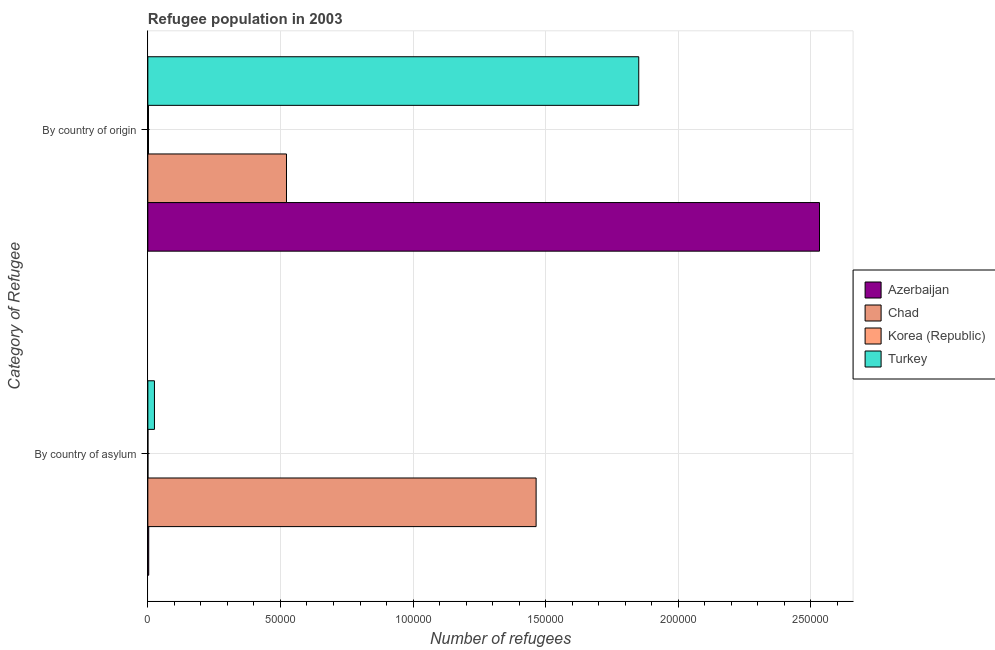How many different coloured bars are there?
Offer a very short reply. 4. Are the number of bars per tick equal to the number of legend labels?
Your response must be concise. Yes. Are the number of bars on each tick of the Y-axis equal?
Your answer should be compact. Yes. How many bars are there on the 2nd tick from the bottom?
Your answer should be compact. 4. What is the label of the 1st group of bars from the top?
Give a very brief answer. By country of origin. What is the number of refugees by country of asylum in Chad?
Offer a terse response. 1.46e+05. Across all countries, what is the maximum number of refugees by country of asylum?
Make the answer very short. 1.46e+05. Across all countries, what is the minimum number of refugees by country of asylum?
Your answer should be very brief. 25. In which country was the number of refugees by country of origin maximum?
Offer a very short reply. Azerbaijan. What is the total number of refugees by country of asylum in the graph?
Provide a succinct answer. 1.49e+05. What is the difference between the number of refugees by country of asylum in Chad and that in Turkey?
Your answer should be compact. 1.44e+05. What is the difference between the number of refugees by country of origin in Korea (Republic) and the number of refugees by country of asylum in Chad?
Your response must be concise. -1.46e+05. What is the average number of refugees by country of asylum per country?
Give a very brief answer. 3.73e+04. What is the difference between the number of refugees by country of origin and number of refugees by country of asylum in Azerbaijan?
Your answer should be compact. 2.53e+05. What is the ratio of the number of refugees by country of origin in Korea (Republic) to that in Turkey?
Make the answer very short. 0. Is the number of refugees by country of origin in Korea (Republic) less than that in Chad?
Your response must be concise. Yes. In how many countries, is the number of refugees by country of origin greater than the average number of refugees by country of origin taken over all countries?
Provide a succinct answer. 2. What does the 2nd bar from the top in By country of origin represents?
Offer a terse response. Korea (Republic). What does the 1st bar from the bottom in By country of asylum represents?
Give a very brief answer. Azerbaijan. How many bars are there?
Your answer should be compact. 8. Are all the bars in the graph horizontal?
Offer a terse response. Yes. How many countries are there in the graph?
Keep it short and to the point. 4. Does the graph contain any zero values?
Offer a very short reply. No. How many legend labels are there?
Ensure brevity in your answer.  4. What is the title of the graph?
Your answer should be very brief. Refugee population in 2003. Does "Oman" appear as one of the legend labels in the graph?
Offer a very short reply. No. What is the label or title of the X-axis?
Provide a succinct answer. Number of refugees. What is the label or title of the Y-axis?
Provide a short and direct response. Category of Refugee. What is the Number of refugees of Azerbaijan in By country of asylum?
Your response must be concise. 326. What is the Number of refugees of Chad in By country of asylum?
Make the answer very short. 1.46e+05. What is the Number of refugees in Turkey in By country of asylum?
Make the answer very short. 2490. What is the Number of refugees in Azerbaijan in By country of origin?
Your response must be concise. 2.53e+05. What is the Number of refugees in Chad in By country of origin?
Make the answer very short. 5.23e+04. What is the Number of refugees of Korea (Republic) in By country of origin?
Provide a short and direct response. 237. What is the Number of refugees of Turkey in By country of origin?
Keep it short and to the point. 1.85e+05. Across all Category of Refugee, what is the maximum Number of refugees in Azerbaijan?
Offer a very short reply. 2.53e+05. Across all Category of Refugee, what is the maximum Number of refugees of Chad?
Your answer should be compact. 1.46e+05. Across all Category of Refugee, what is the maximum Number of refugees in Korea (Republic)?
Your response must be concise. 237. Across all Category of Refugee, what is the maximum Number of refugees of Turkey?
Ensure brevity in your answer.  1.85e+05. Across all Category of Refugee, what is the minimum Number of refugees of Azerbaijan?
Offer a very short reply. 326. Across all Category of Refugee, what is the minimum Number of refugees in Chad?
Your answer should be very brief. 5.23e+04. Across all Category of Refugee, what is the minimum Number of refugees of Turkey?
Offer a very short reply. 2490. What is the total Number of refugees in Azerbaijan in the graph?
Provide a short and direct response. 2.54e+05. What is the total Number of refugees of Chad in the graph?
Give a very brief answer. 1.99e+05. What is the total Number of refugees of Korea (Republic) in the graph?
Ensure brevity in your answer.  262. What is the total Number of refugees of Turkey in the graph?
Your response must be concise. 1.88e+05. What is the difference between the Number of refugees in Azerbaijan in By country of asylum and that in By country of origin?
Your response must be concise. -2.53e+05. What is the difference between the Number of refugees in Chad in By country of asylum and that in By country of origin?
Your answer should be compact. 9.41e+04. What is the difference between the Number of refugees in Korea (Republic) in By country of asylum and that in By country of origin?
Ensure brevity in your answer.  -212. What is the difference between the Number of refugees of Turkey in By country of asylum and that in By country of origin?
Your answer should be compact. -1.83e+05. What is the difference between the Number of refugees in Azerbaijan in By country of asylum and the Number of refugees in Chad in By country of origin?
Your response must be concise. -5.19e+04. What is the difference between the Number of refugees of Azerbaijan in By country of asylum and the Number of refugees of Korea (Republic) in By country of origin?
Give a very brief answer. 89. What is the difference between the Number of refugees in Azerbaijan in By country of asylum and the Number of refugees in Turkey in By country of origin?
Make the answer very short. -1.85e+05. What is the difference between the Number of refugees in Chad in By country of asylum and the Number of refugees in Korea (Republic) in By country of origin?
Keep it short and to the point. 1.46e+05. What is the difference between the Number of refugees in Chad in By country of asylum and the Number of refugees in Turkey in By country of origin?
Give a very brief answer. -3.87e+04. What is the difference between the Number of refugees in Korea (Republic) in By country of asylum and the Number of refugees in Turkey in By country of origin?
Your answer should be very brief. -1.85e+05. What is the average Number of refugees in Azerbaijan per Category of Refugee?
Ensure brevity in your answer.  1.27e+05. What is the average Number of refugees of Chad per Category of Refugee?
Your answer should be very brief. 9.93e+04. What is the average Number of refugees in Korea (Republic) per Category of Refugee?
Offer a very short reply. 131. What is the average Number of refugees in Turkey per Category of Refugee?
Provide a short and direct response. 9.38e+04. What is the difference between the Number of refugees in Azerbaijan and Number of refugees in Chad in By country of asylum?
Your response must be concise. -1.46e+05. What is the difference between the Number of refugees of Azerbaijan and Number of refugees of Korea (Republic) in By country of asylum?
Make the answer very short. 301. What is the difference between the Number of refugees in Azerbaijan and Number of refugees in Turkey in By country of asylum?
Your answer should be compact. -2164. What is the difference between the Number of refugees in Chad and Number of refugees in Korea (Republic) in By country of asylum?
Your answer should be very brief. 1.46e+05. What is the difference between the Number of refugees of Chad and Number of refugees of Turkey in By country of asylum?
Make the answer very short. 1.44e+05. What is the difference between the Number of refugees in Korea (Republic) and Number of refugees in Turkey in By country of asylum?
Offer a very short reply. -2465. What is the difference between the Number of refugees in Azerbaijan and Number of refugees in Chad in By country of origin?
Offer a terse response. 2.01e+05. What is the difference between the Number of refugees in Azerbaijan and Number of refugees in Korea (Republic) in By country of origin?
Make the answer very short. 2.53e+05. What is the difference between the Number of refugees in Azerbaijan and Number of refugees in Turkey in By country of origin?
Your response must be concise. 6.82e+04. What is the difference between the Number of refugees in Chad and Number of refugees in Korea (Republic) in By country of origin?
Keep it short and to the point. 5.20e+04. What is the difference between the Number of refugees in Chad and Number of refugees in Turkey in By country of origin?
Your answer should be compact. -1.33e+05. What is the difference between the Number of refugees in Korea (Republic) and Number of refugees in Turkey in By country of origin?
Provide a short and direct response. -1.85e+05. What is the ratio of the Number of refugees in Azerbaijan in By country of asylum to that in By country of origin?
Keep it short and to the point. 0. What is the ratio of the Number of refugees in Chad in By country of asylum to that in By country of origin?
Give a very brief answer. 2.8. What is the ratio of the Number of refugees in Korea (Republic) in By country of asylum to that in By country of origin?
Your answer should be compact. 0.11. What is the ratio of the Number of refugees of Turkey in By country of asylum to that in By country of origin?
Make the answer very short. 0.01. What is the difference between the highest and the second highest Number of refugees in Azerbaijan?
Offer a terse response. 2.53e+05. What is the difference between the highest and the second highest Number of refugees in Chad?
Give a very brief answer. 9.41e+04. What is the difference between the highest and the second highest Number of refugees in Korea (Republic)?
Your answer should be very brief. 212. What is the difference between the highest and the second highest Number of refugees in Turkey?
Your answer should be compact. 1.83e+05. What is the difference between the highest and the lowest Number of refugees of Azerbaijan?
Offer a very short reply. 2.53e+05. What is the difference between the highest and the lowest Number of refugees of Chad?
Give a very brief answer. 9.41e+04. What is the difference between the highest and the lowest Number of refugees of Korea (Republic)?
Keep it short and to the point. 212. What is the difference between the highest and the lowest Number of refugees of Turkey?
Your answer should be very brief. 1.83e+05. 